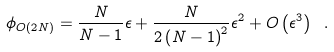Convert formula to latex. <formula><loc_0><loc_0><loc_500><loc_500>\phi _ { O ( 2 N ) } = \frac { N } { N - 1 } \epsilon + \frac { N } { 2 \left ( N - 1 \right ) ^ { 2 } } \epsilon ^ { 2 } + O \left ( \epsilon ^ { 3 } \right ) \ .</formula> 